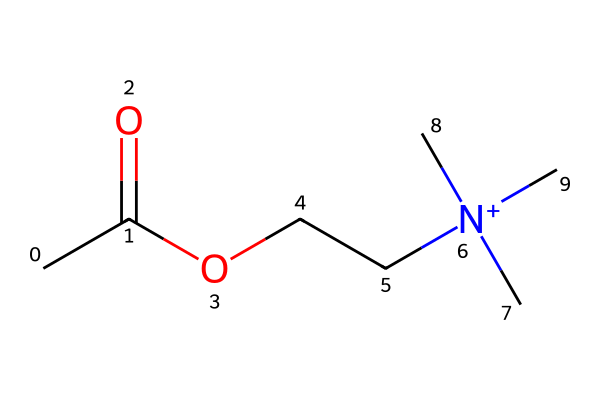What is the chemical name for the compound represented by this SMILES? The SMILES notation indicates the structure of acetylcholine, which is a well-known neurotransmitter. The presence of the acetyl (CC(=O)) group and the quaternary ammonium group ([N+](C)(C)C) confirms its identity.
Answer: acetylcholine How many carbon atoms are in this molecule? Analyzing the SMILES notation, there are five carbon atoms present in the structure (CC(=O)OCC[N+](C)(C)C contains 5 C's).
Answer: 5 What type of functional group is present at the beginning of the molecule? The SMILES begins with "CC(=O)", which indicates a carbonyl group (an acyl group), specifically an acetyl group, characterizing this as an ester functional group due to the subsequent oxygen.
Answer: acetyl group What charge does the nitrogen atom in this compound carry? The nitrogen is represented as [N+](C)(C)C, indicating it carries a positive charge because of the four bonds it forms (three with methyl groups and one with the ethoxy group).
Answer: positive What property relates acetylcholine to its role as a neurotransmitter? The presence of the quaternary ammonium structure ([N+](C)(C)C) provides acetylcholine with its ionic character, essential for its interaction with acetylcholine receptors in the nervous system.
Answer: ionic character What type of bond connects the acetyl group to the oxygen in this molecule? The acetyl group is connected to the oxygen through a single bond, indicated by the arrangement "OCC", where oxygen is bonded to carbon without any double bond representation.
Answer: single bond 